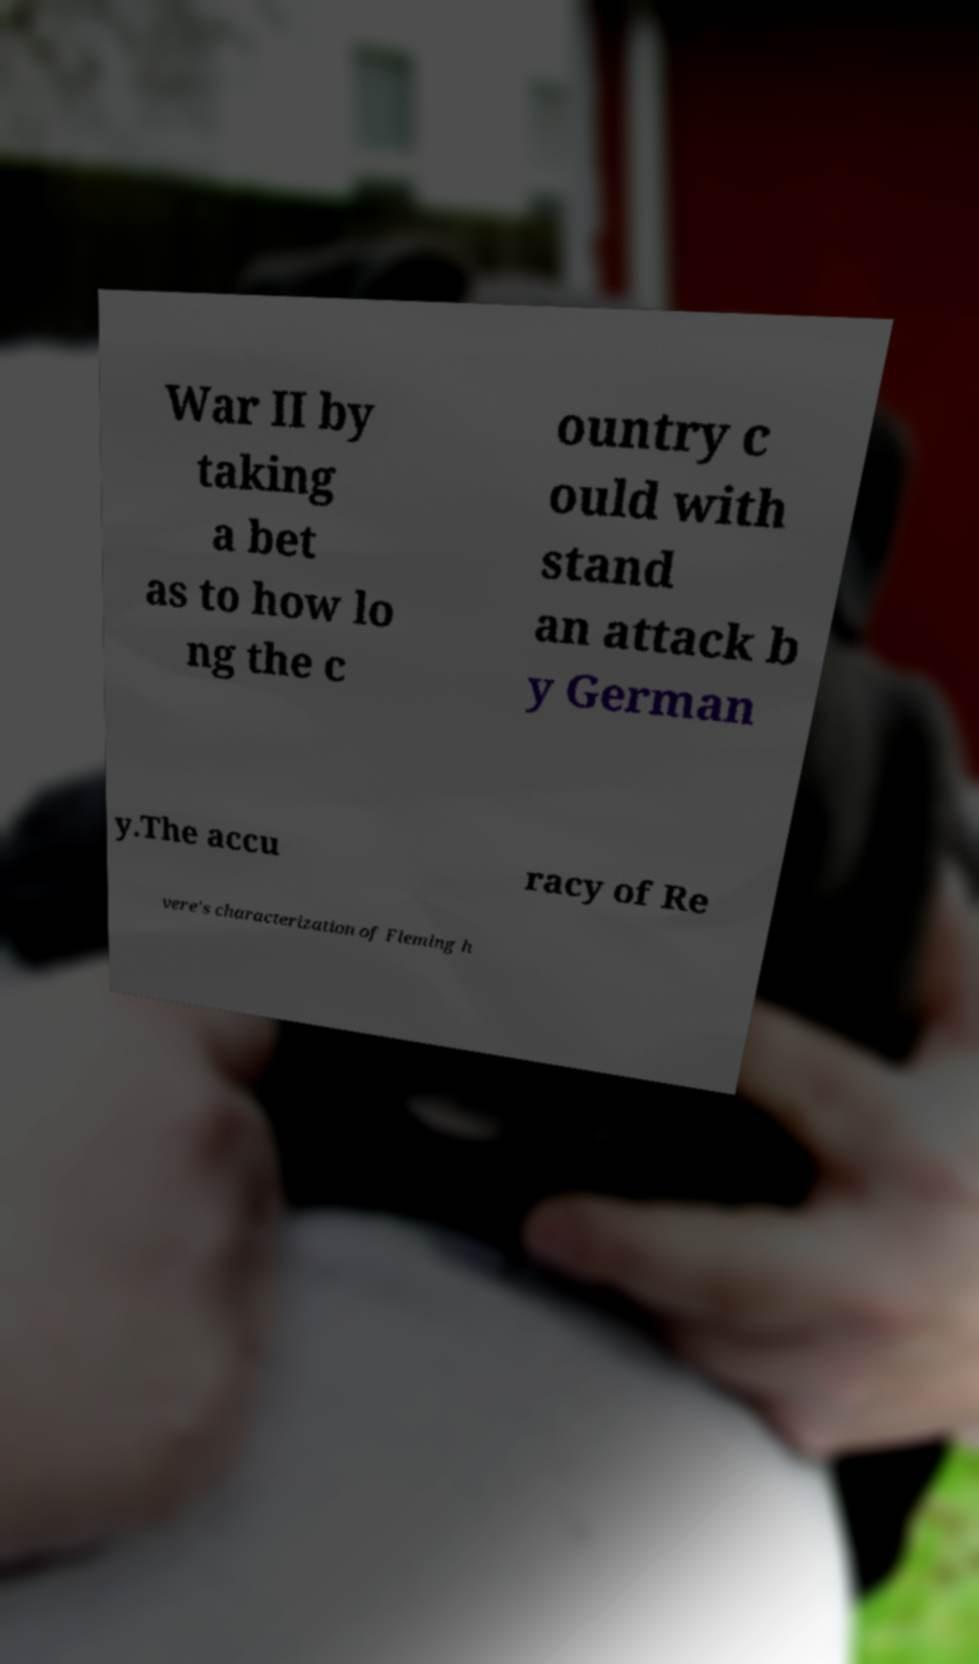For documentation purposes, I need the text within this image transcribed. Could you provide that? War II by taking a bet as to how lo ng the c ountry c ould with stand an attack b y German y.The accu racy of Re vere's characterization of Fleming h 